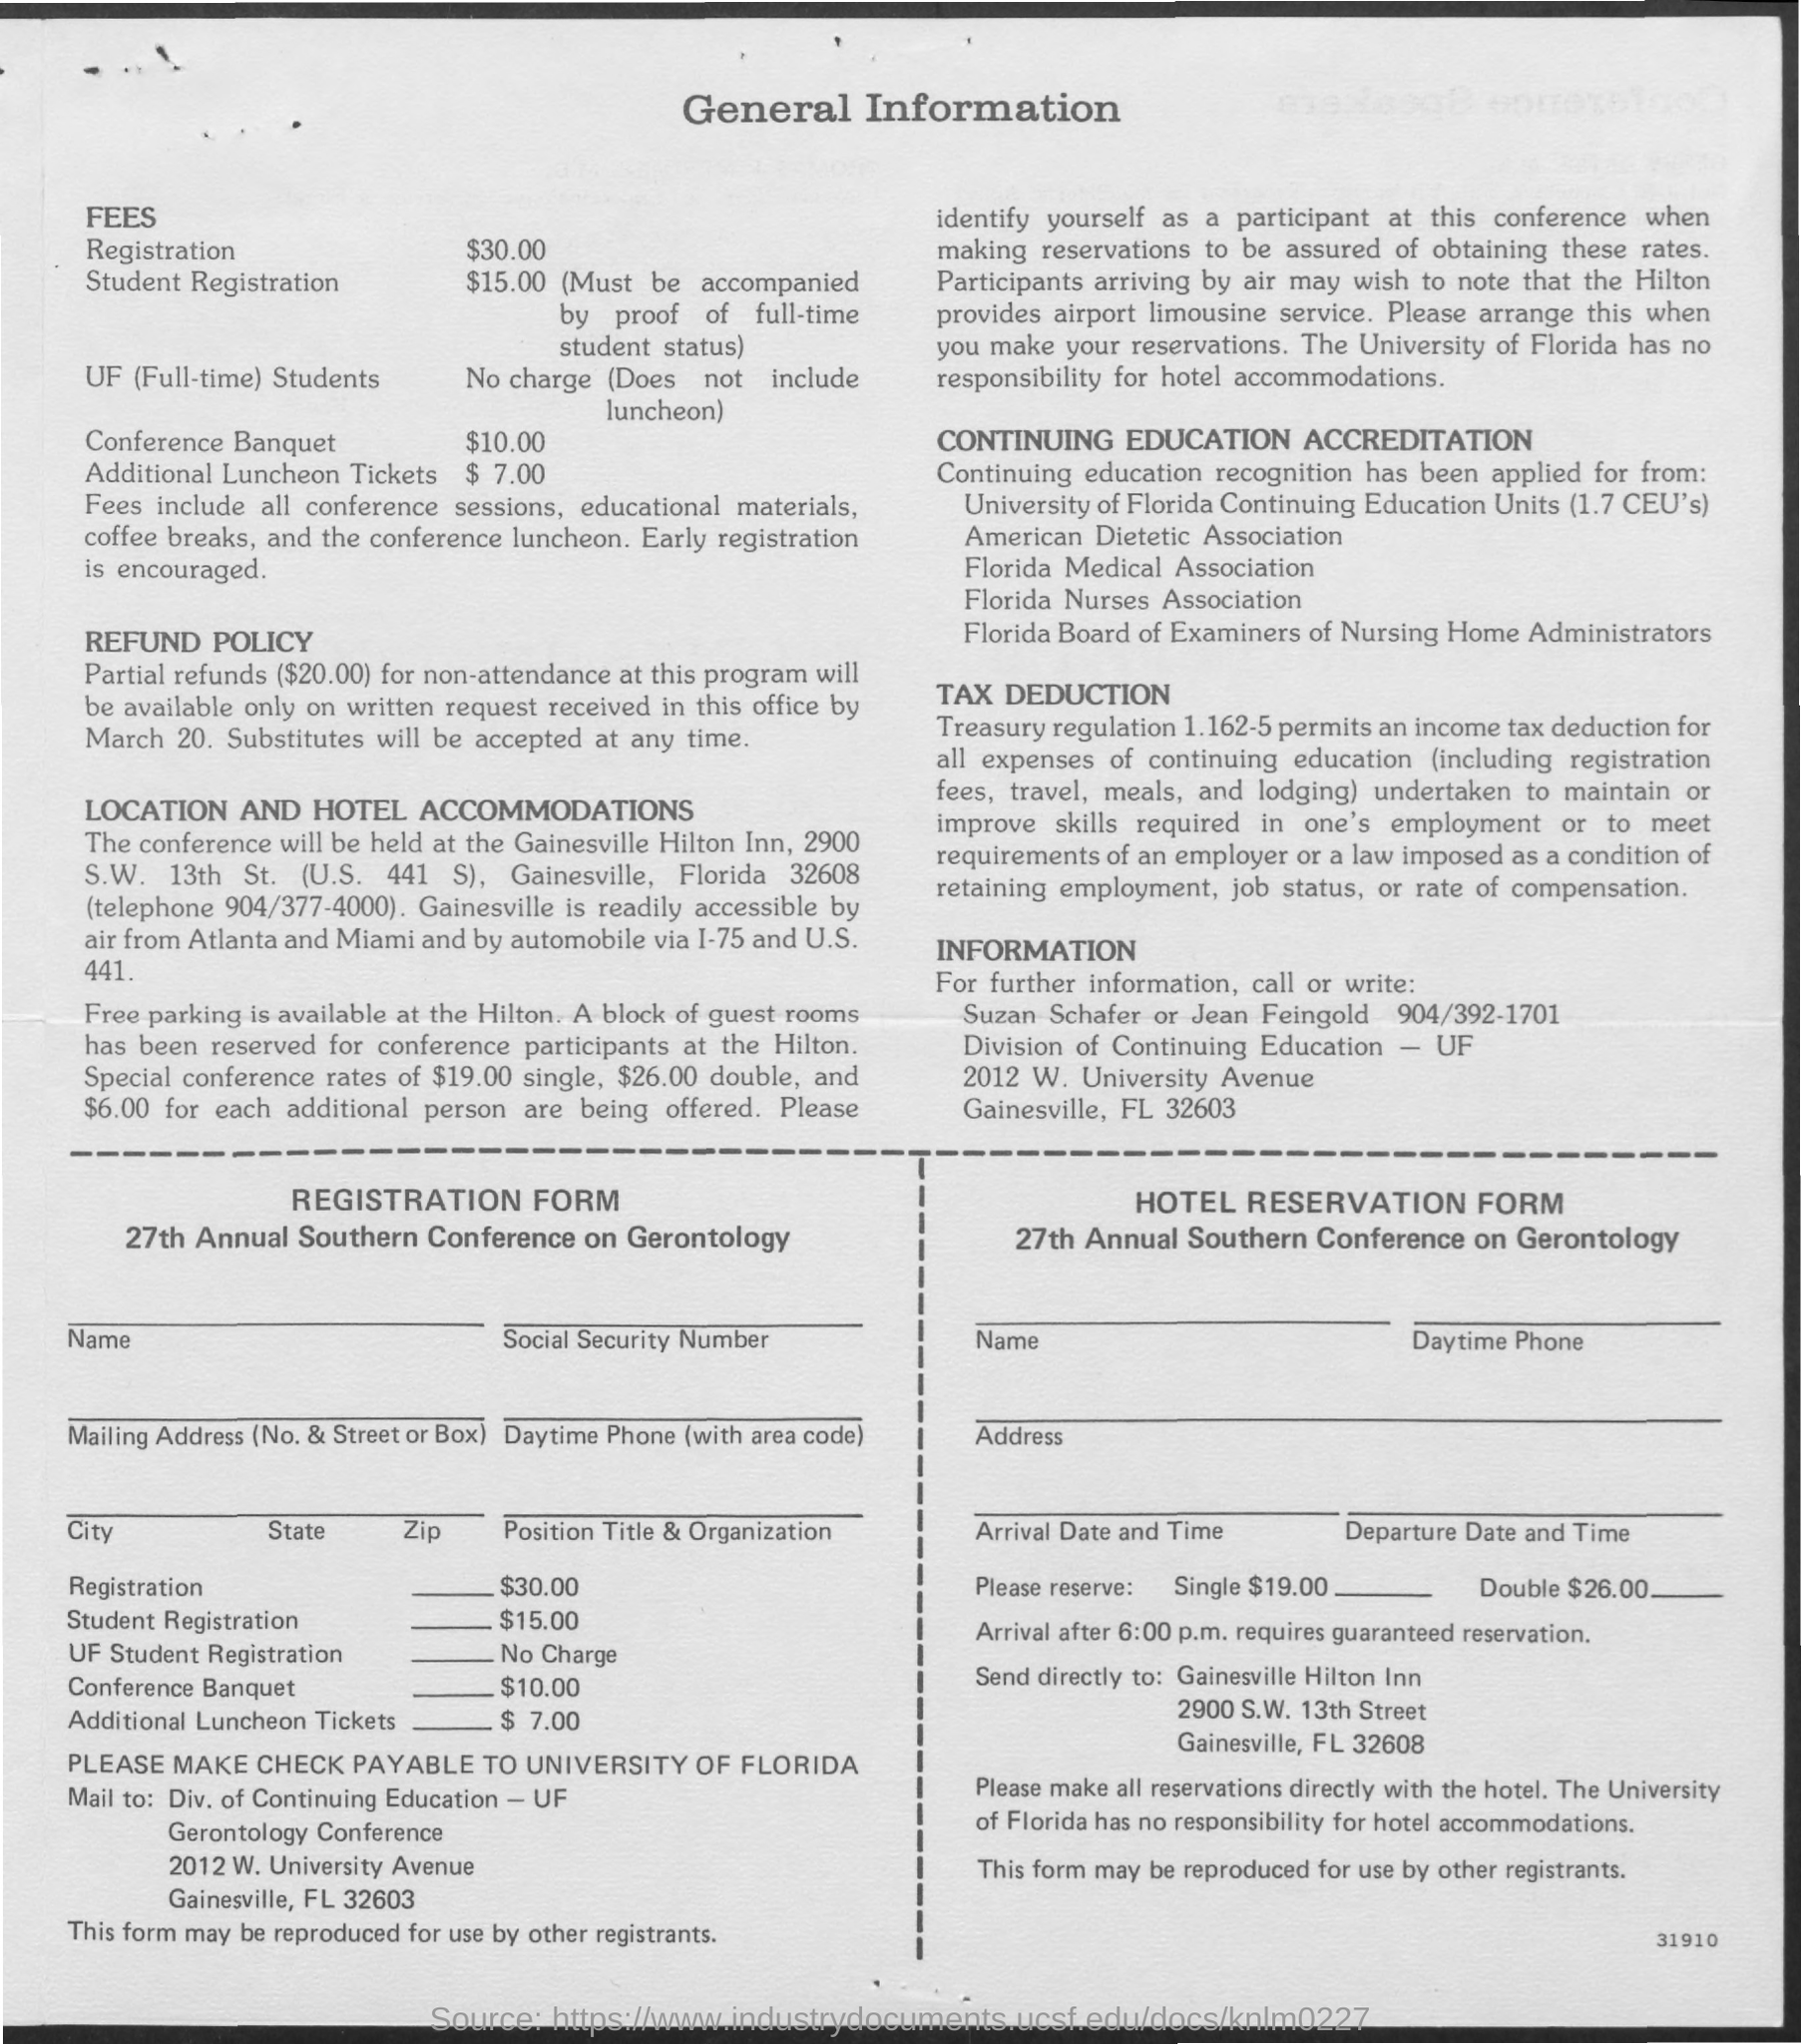What is the Registration fee for the 27th Annual Southern Conference on Gerontology?
Provide a short and direct response. $30.00. What is the student registration fee for the 27th Annual Southern Conference on Gerontology?
Offer a very short reply. $15.00. What is the UF Student registration fee for 27th Annual Southern Conference on Gerontology?
Give a very brief answer. No Charge. What is the cost for Conference Banquet?
Provide a succinct answer. $10.00. 